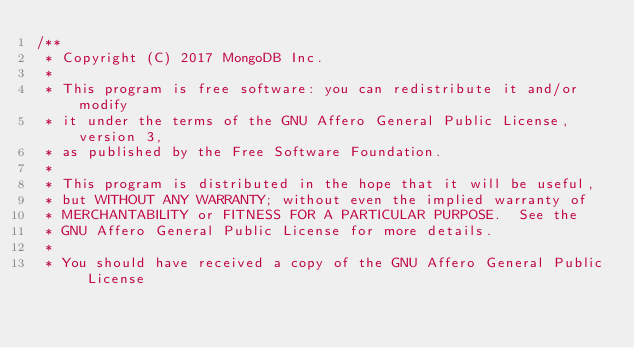Convert code to text. <code><loc_0><loc_0><loc_500><loc_500><_C++_>/**
 * Copyright (C) 2017 MongoDB Inc.
 *
 * This program is free software: you can redistribute it and/or  modify
 * it under the terms of the GNU Affero General Public License, version 3,
 * as published by the Free Software Foundation.
 *
 * This program is distributed in the hope that it will be useful,
 * but WITHOUT ANY WARRANTY; without even the implied warranty of
 * MERCHANTABILITY or FITNESS FOR A PARTICULAR PURPOSE.  See the
 * GNU Affero General Public License for more details.
 *
 * You should have received a copy of the GNU Affero General Public License</code> 